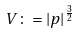Convert formula to latex. <formula><loc_0><loc_0><loc_500><loc_500>V \colon = | p | ^ { \frac { 3 } { 2 } }</formula> 